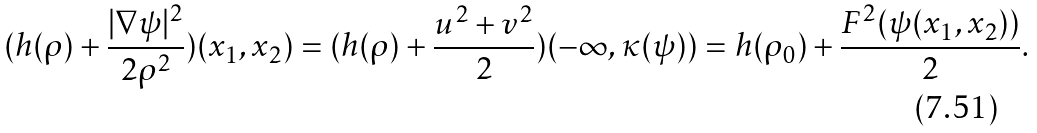Convert formula to latex. <formula><loc_0><loc_0><loc_500><loc_500>( h ( \rho ) + \frac { | \nabla \psi | ^ { 2 } } { 2 \rho ^ { 2 } } ) ( x _ { 1 } , x _ { 2 } ) = ( h ( \rho ) + \frac { u ^ { 2 } + v ^ { 2 } } { 2 } ) ( - \infty , \kappa ( \psi ) ) = h ( \rho _ { 0 } ) + \frac { F ^ { 2 } ( \psi ( x _ { 1 } , x _ { 2 } ) ) } { 2 } .</formula> 